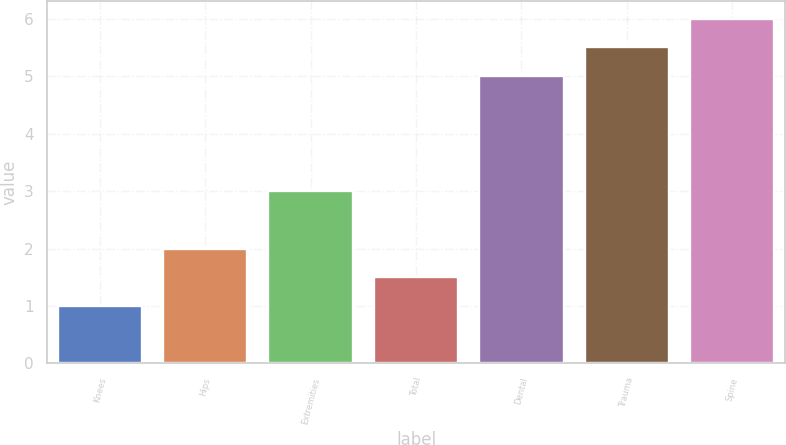<chart> <loc_0><loc_0><loc_500><loc_500><bar_chart><fcel>Knees<fcel>Hips<fcel>Extremities<fcel>Total<fcel>Dental<fcel>Trauma<fcel>Spine<nl><fcel>1<fcel>2<fcel>3<fcel>1.5<fcel>5<fcel>5.5<fcel>6<nl></chart> 